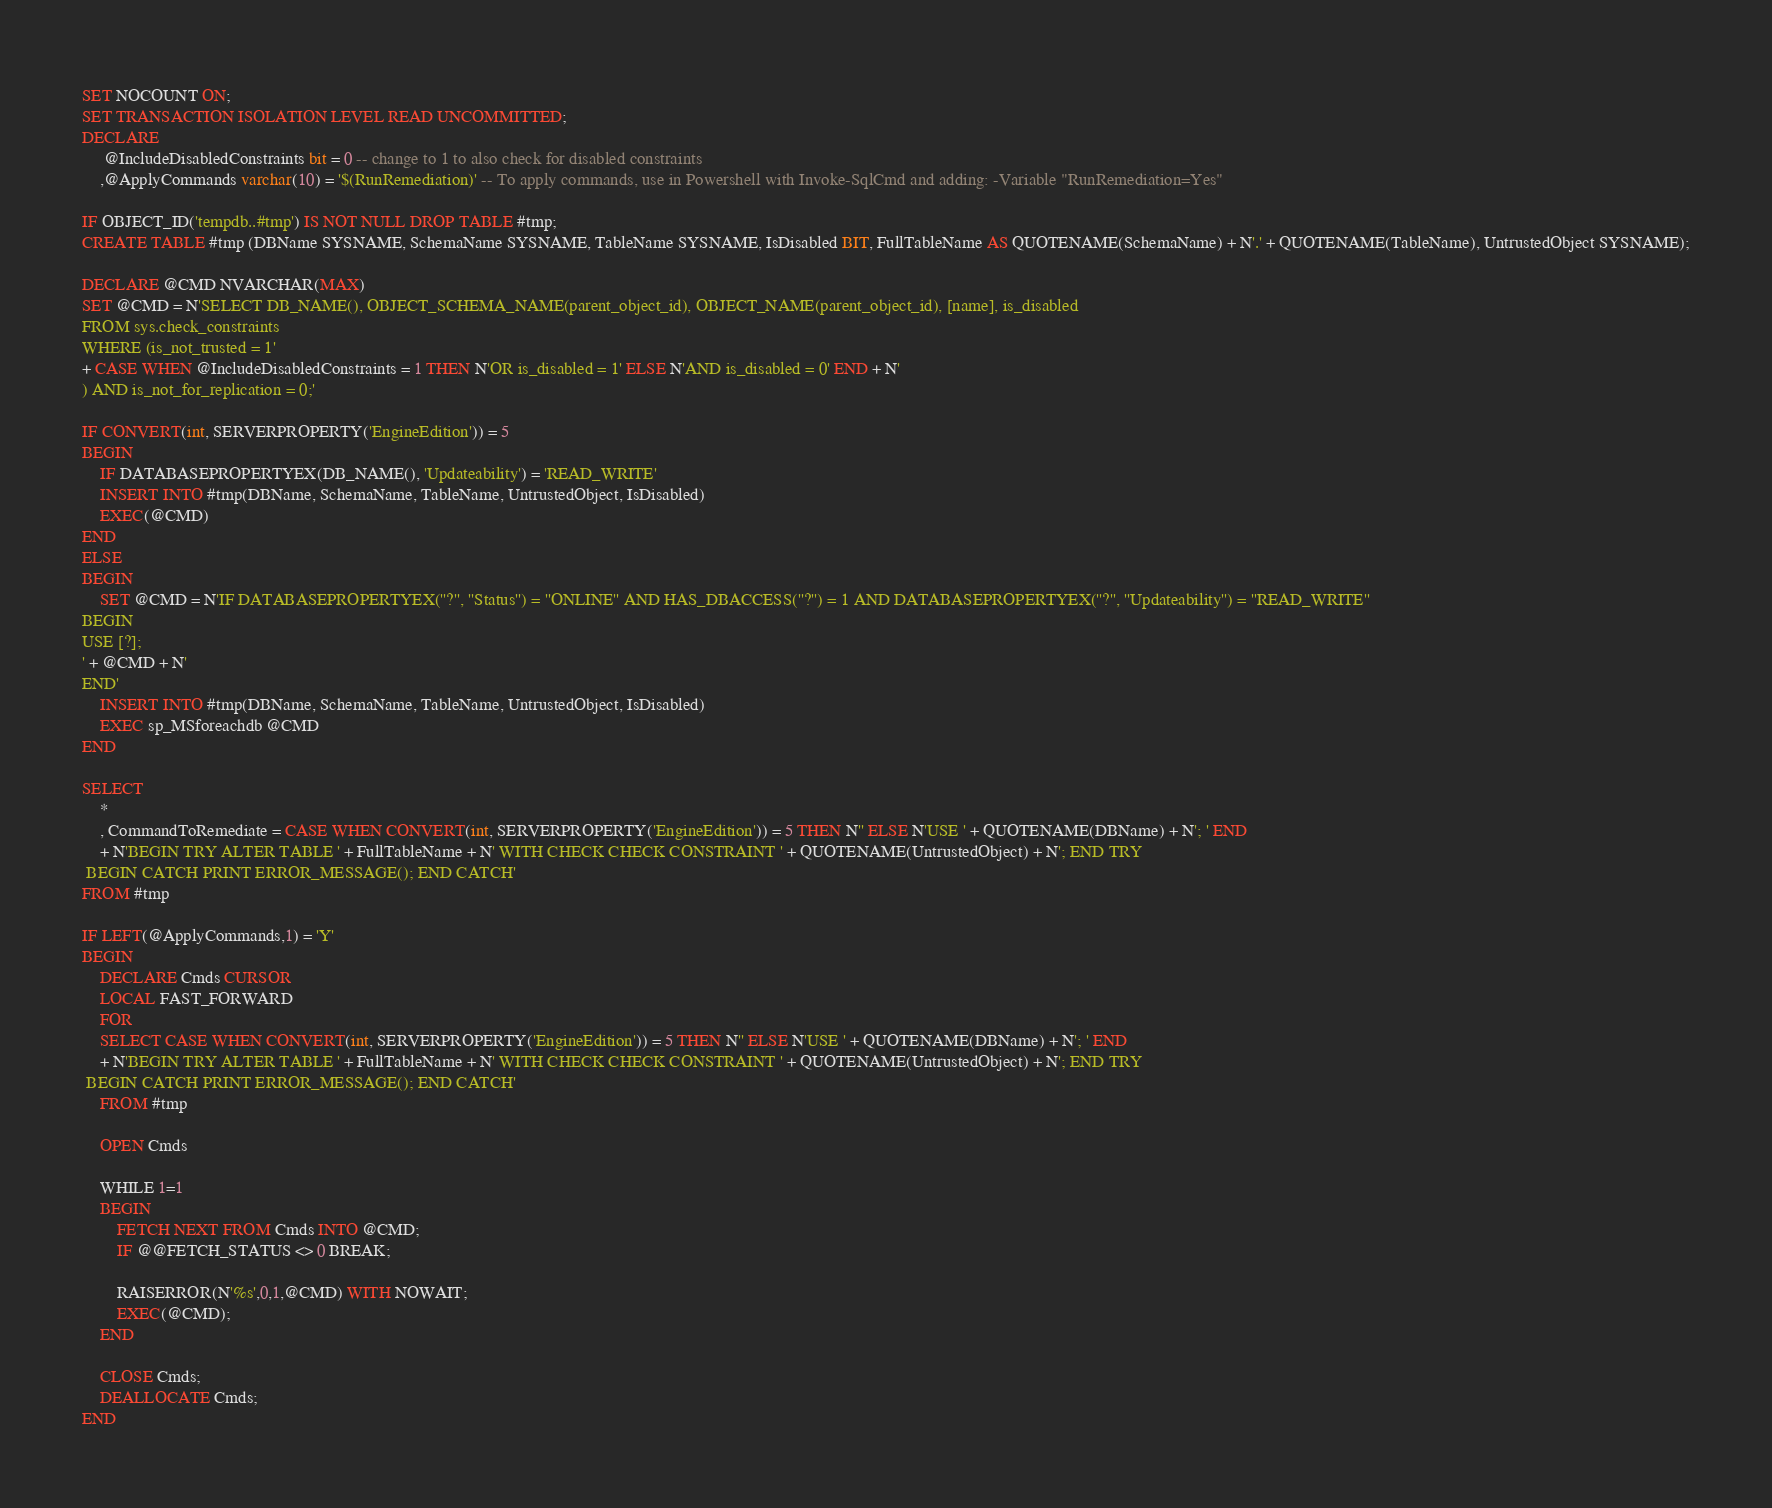<code> <loc_0><loc_0><loc_500><loc_500><_SQL_>SET NOCOUNT ON;
SET TRANSACTION ISOLATION LEVEL READ UNCOMMITTED;
DECLARE
	 @IncludeDisabledConstraints bit = 0 -- change to 1 to also check for disabled constraints
	,@ApplyCommands varchar(10) = '$(RunRemediation)' -- To apply commands, use in Powershell with Invoke-SqlCmd and adding: -Variable "RunRemediation=Yes"

IF OBJECT_ID('tempdb..#tmp') IS NOT NULL DROP TABLE #tmp;
CREATE TABLE #tmp (DBName SYSNAME, SchemaName SYSNAME, TableName SYSNAME, IsDisabled BIT, FullTableName AS QUOTENAME(SchemaName) + N'.' + QUOTENAME(TableName), UntrustedObject SYSNAME);

DECLARE @CMD NVARCHAR(MAX)
SET @CMD = N'SELECT DB_NAME(), OBJECT_SCHEMA_NAME(parent_object_id), OBJECT_NAME(parent_object_id), [name], is_disabled
FROM sys.check_constraints
WHERE (is_not_trusted = 1'
+ CASE WHEN @IncludeDisabledConstraints = 1 THEN N'OR is_disabled = 1' ELSE N'AND is_disabled = 0' END + N'
) AND is_not_for_replication = 0;'

IF CONVERT(int, SERVERPROPERTY('EngineEdition')) = 5
BEGIN
	IF DATABASEPROPERTYEX(DB_NAME(), 'Updateability') = 'READ_WRITE'
	INSERT INTO #tmp(DBName, SchemaName, TableName, UntrustedObject, IsDisabled)
	EXEC(@CMD)
END
ELSE
BEGIN
	SET @CMD = N'IF DATABASEPROPERTYEX(''?'', ''Status'') = ''ONLINE'' AND HAS_DBACCESS(''?'') = 1 AND DATABASEPROPERTYEX(''?'', ''Updateability'') = ''READ_WRITE''
BEGIN
USE [?];
' + @CMD + N'
END'
	INSERT INTO #tmp(DBName, SchemaName, TableName, UntrustedObject, IsDisabled)
	EXEC sp_MSforeachdb @CMD
END
 
SELECT
	*
	, CommandToRemediate = CASE WHEN CONVERT(int, SERVERPROPERTY('EngineEdition')) = 5 THEN N'' ELSE N'USE ' + QUOTENAME(DBName) + N'; ' END
	+ N'BEGIN TRY ALTER TABLE ' + FullTableName + N' WITH CHECK CHECK CONSTRAINT ' + QUOTENAME(UntrustedObject) + N'; END TRY
 BEGIN CATCH PRINT ERROR_MESSAGE(); END CATCH'
FROM #tmp

IF LEFT(@ApplyCommands,1) = 'Y'
BEGIN
	DECLARE Cmds CURSOR
	LOCAL FAST_FORWARD
	FOR
	SELECT CASE WHEN CONVERT(int, SERVERPROPERTY('EngineEdition')) = 5 THEN N'' ELSE N'USE ' + QUOTENAME(DBName) + N'; ' END
	+ N'BEGIN TRY ALTER TABLE ' + FullTableName + N' WITH CHECK CHECK CONSTRAINT ' + QUOTENAME(UntrustedObject) + N'; END TRY
 BEGIN CATCH PRINT ERROR_MESSAGE(); END CATCH'
	FROM #tmp

	OPEN Cmds

	WHILE 1=1
	BEGIN
		FETCH NEXT FROM Cmds INTO @CMD;
		IF @@FETCH_STATUS <> 0 BREAK;

		RAISERROR(N'%s',0,1,@CMD) WITH NOWAIT;
		EXEC(@CMD);
	END

	CLOSE Cmds;
	DEALLOCATE Cmds;
END</code> 